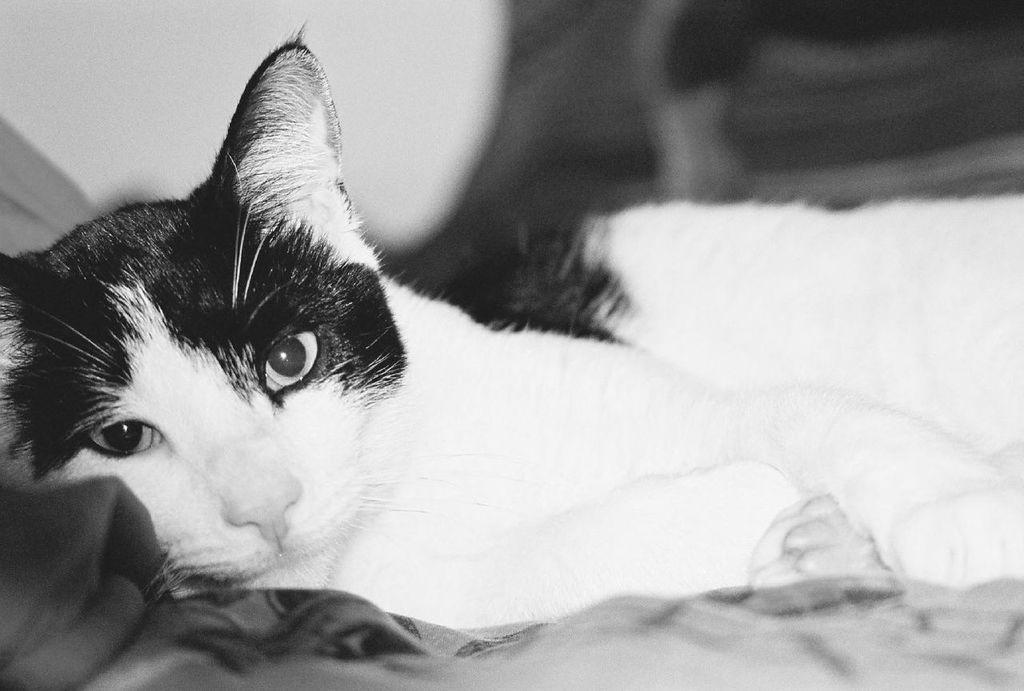Describe this image in one or two sentences. In this image I can see a cat is sleeping. The image is in black and white. 